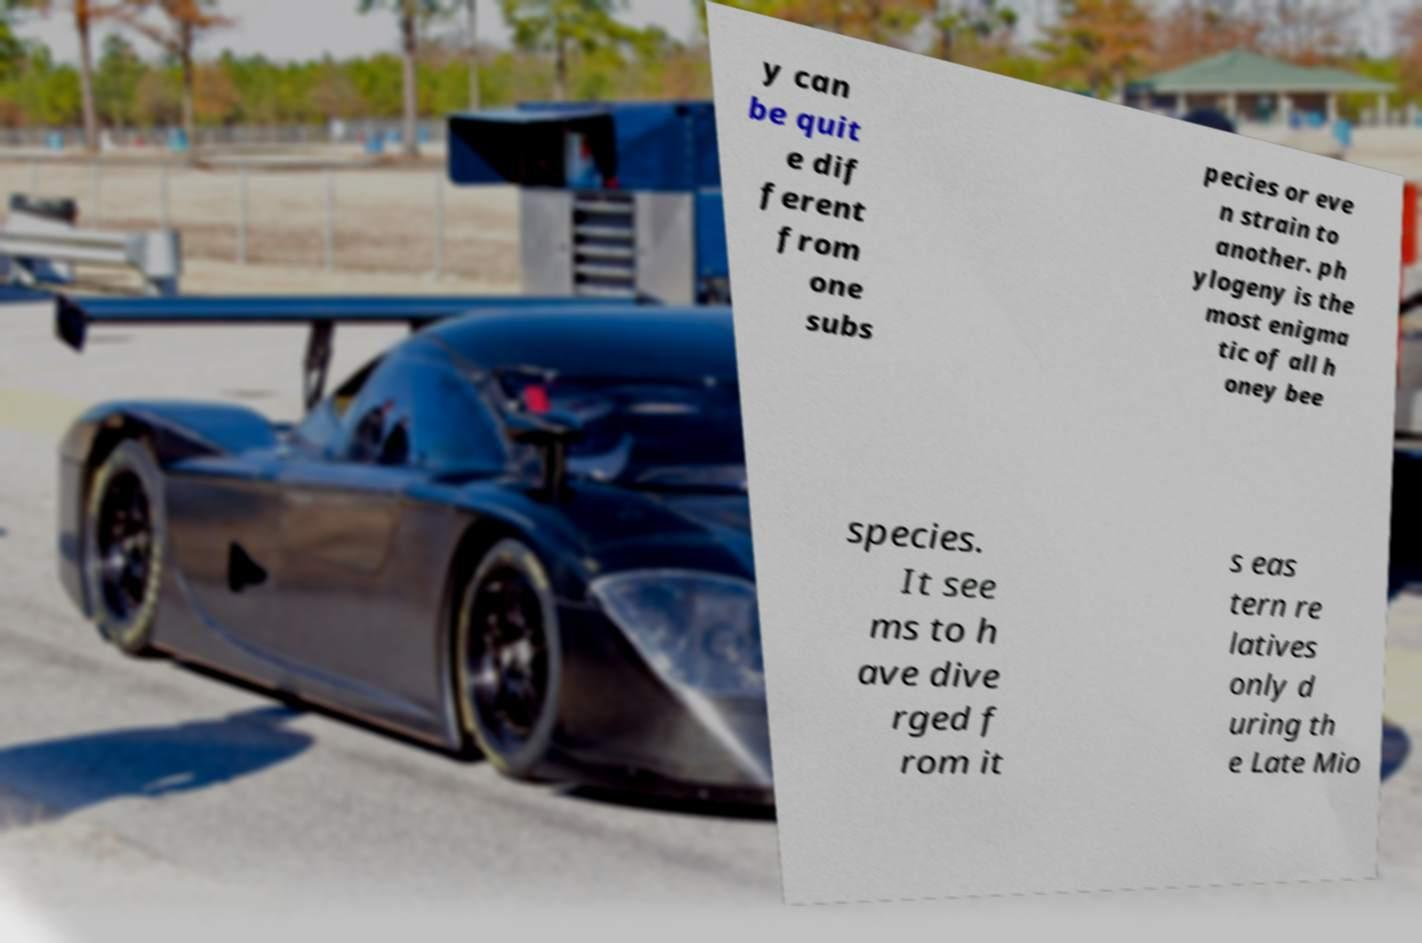For documentation purposes, I need the text within this image transcribed. Could you provide that? y can be quit e dif ferent from one subs pecies or eve n strain to another. ph ylogeny is the most enigma tic of all h oney bee species. It see ms to h ave dive rged f rom it s eas tern re latives only d uring th e Late Mio 